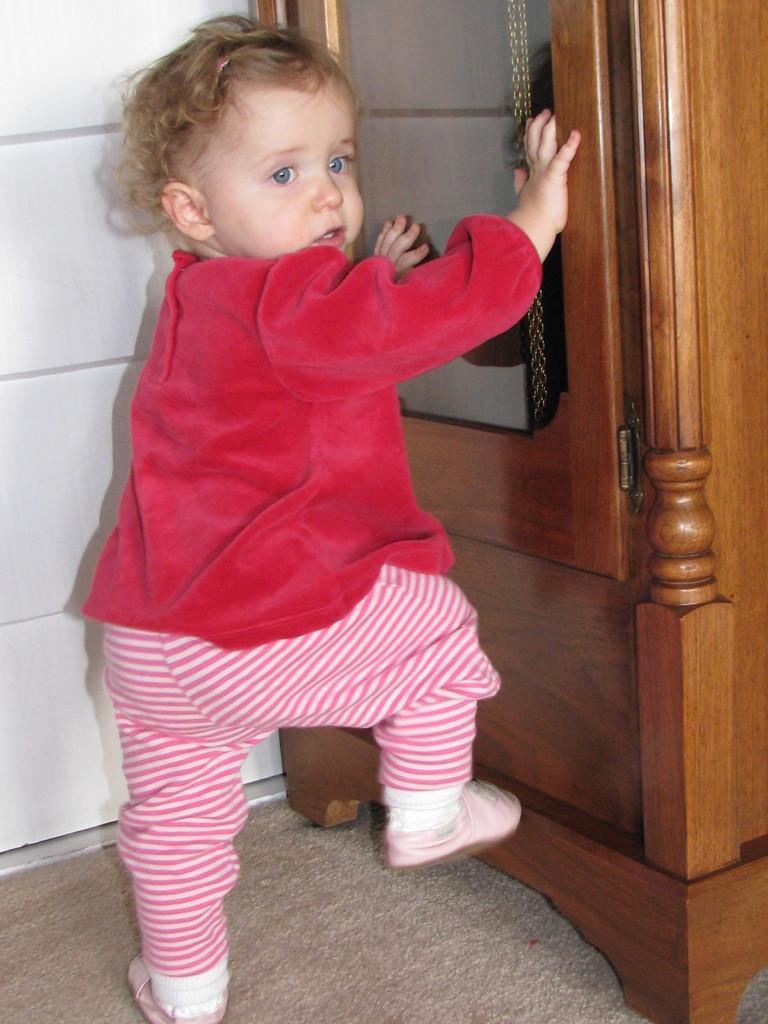Describe this image in one or two sentences. In the image we can see a baby wearing clothes and shoes. Here we can see a wooden cabinet, carpet and a wall. 